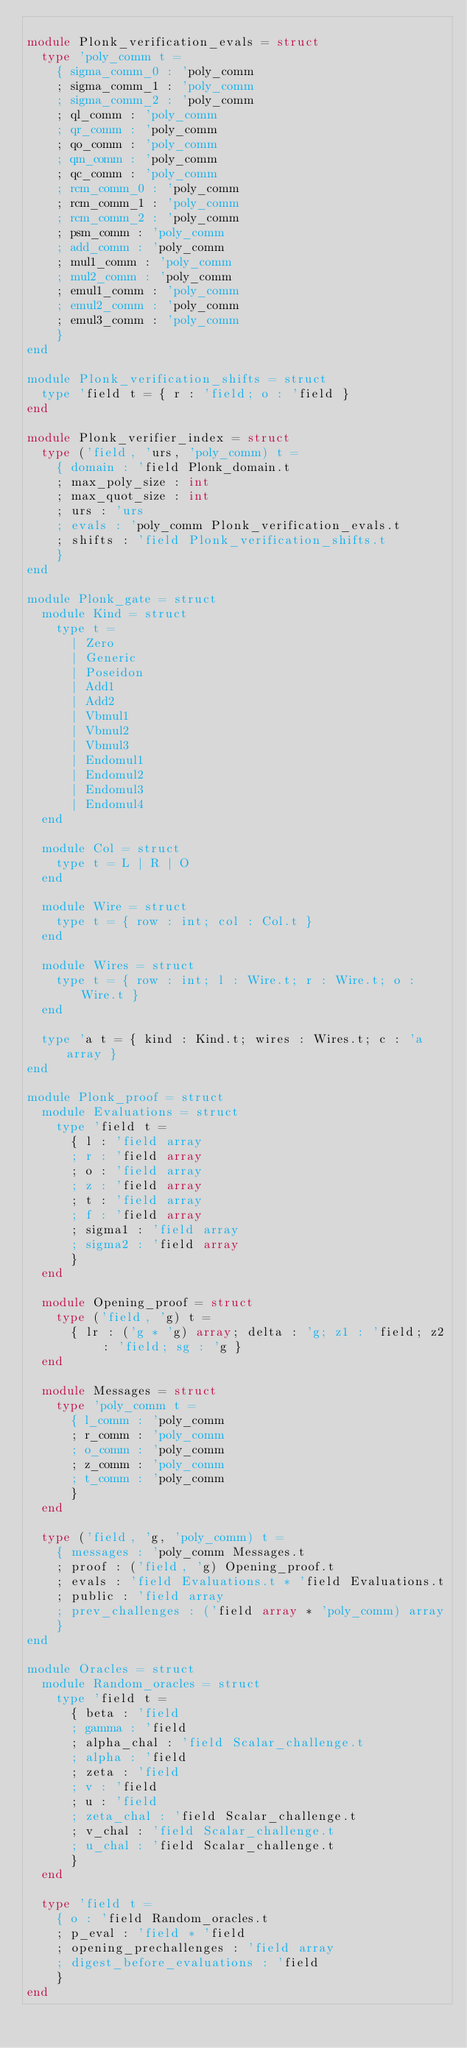<code> <loc_0><loc_0><loc_500><loc_500><_OCaml_>
module Plonk_verification_evals = struct
  type 'poly_comm t =
    { sigma_comm_0 : 'poly_comm
    ; sigma_comm_1 : 'poly_comm
    ; sigma_comm_2 : 'poly_comm
    ; ql_comm : 'poly_comm
    ; qr_comm : 'poly_comm
    ; qo_comm : 'poly_comm
    ; qm_comm : 'poly_comm
    ; qc_comm : 'poly_comm
    ; rcm_comm_0 : 'poly_comm
    ; rcm_comm_1 : 'poly_comm
    ; rcm_comm_2 : 'poly_comm
    ; psm_comm : 'poly_comm
    ; add_comm : 'poly_comm
    ; mul1_comm : 'poly_comm
    ; mul2_comm : 'poly_comm
    ; emul1_comm : 'poly_comm
    ; emul2_comm : 'poly_comm
    ; emul3_comm : 'poly_comm
    }
end

module Plonk_verification_shifts = struct
  type 'field t = { r : 'field; o : 'field }
end

module Plonk_verifier_index = struct
  type ('field, 'urs, 'poly_comm) t =
    { domain : 'field Plonk_domain.t
    ; max_poly_size : int
    ; max_quot_size : int
    ; urs : 'urs
    ; evals : 'poly_comm Plonk_verification_evals.t
    ; shifts : 'field Plonk_verification_shifts.t
    }
end

module Plonk_gate = struct
  module Kind = struct
    type t =
      | Zero
      | Generic
      | Poseidon
      | Add1
      | Add2
      | Vbmul1
      | Vbmul2
      | Vbmul3
      | Endomul1
      | Endomul2
      | Endomul3
      | Endomul4
  end

  module Col = struct
    type t = L | R | O
  end

  module Wire = struct
    type t = { row : int; col : Col.t }
  end

  module Wires = struct
    type t = { row : int; l : Wire.t; r : Wire.t; o : Wire.t }
  end

  type 'a t = { kind : Kind.t; wires : Wires.t; c : 'a array }
end

module Plonk_proof = struct
  module Evaluations = struct
    type 'field t =
      { l : 'field array
      ; r : 'field array
      ; o : 'field array
      ; z : 'field array
      ; t : 'field array
      ; f : 'field array
      ; sigma1 : 'field array
      ; sigma2 : 'field array
      }
  end

  module Opening_proof = struct
    type ('field, 'g) t =
      { lr : ('g * 'g) array; delta : 'g; z1 : 'field; z2 : 'field; sg : 'g }
  end

  module Messages = struct
    type 'poly_comm t =
      { l_comm : 'poly_comm
      ; r_comm : 'poly_comm
      ; o_comm : 'poly_comm
      ; z_comm : 'poly_comm
      ; t_comm : 'poly_comm
      }
  end

  type ('field, 'g, 'poly_comm) t =
    { messages : 'poly_comm Messages.t
    ; proof : ('field, 'g) Opening_proof.t
    ; evals : 'field Evaluations.t * 'field Evaluations.t
    ; public : 'field array
    ; prev_challenges : ('field array * 'poly_comm) array
    }
end

module Oracles = struct
  module Random_oracles = struct
    type 'field t =
      { beta : 'field
      ; gamma : 'field
      ; alpha_chal : 'field Scalar_challenge.t
      ; alpha : 'field
      ; zeta : 'field
      ; v : 'field
      ; u : 'field
      ; zeta_chal : 'field Scalar_challenge.t
      ; v_chal : 'field Scalar_challenge.t
      ; u_chal : 'field Scalar_challenge.t
      }
  end

  type 'field t =
    { o : 'field Random_oracles.t
    ; p_eval : 'field * 'field
    ; opening_prechallenges : 'field array
    ; digest_before_evaluations : 'field
    }
end
</code> 